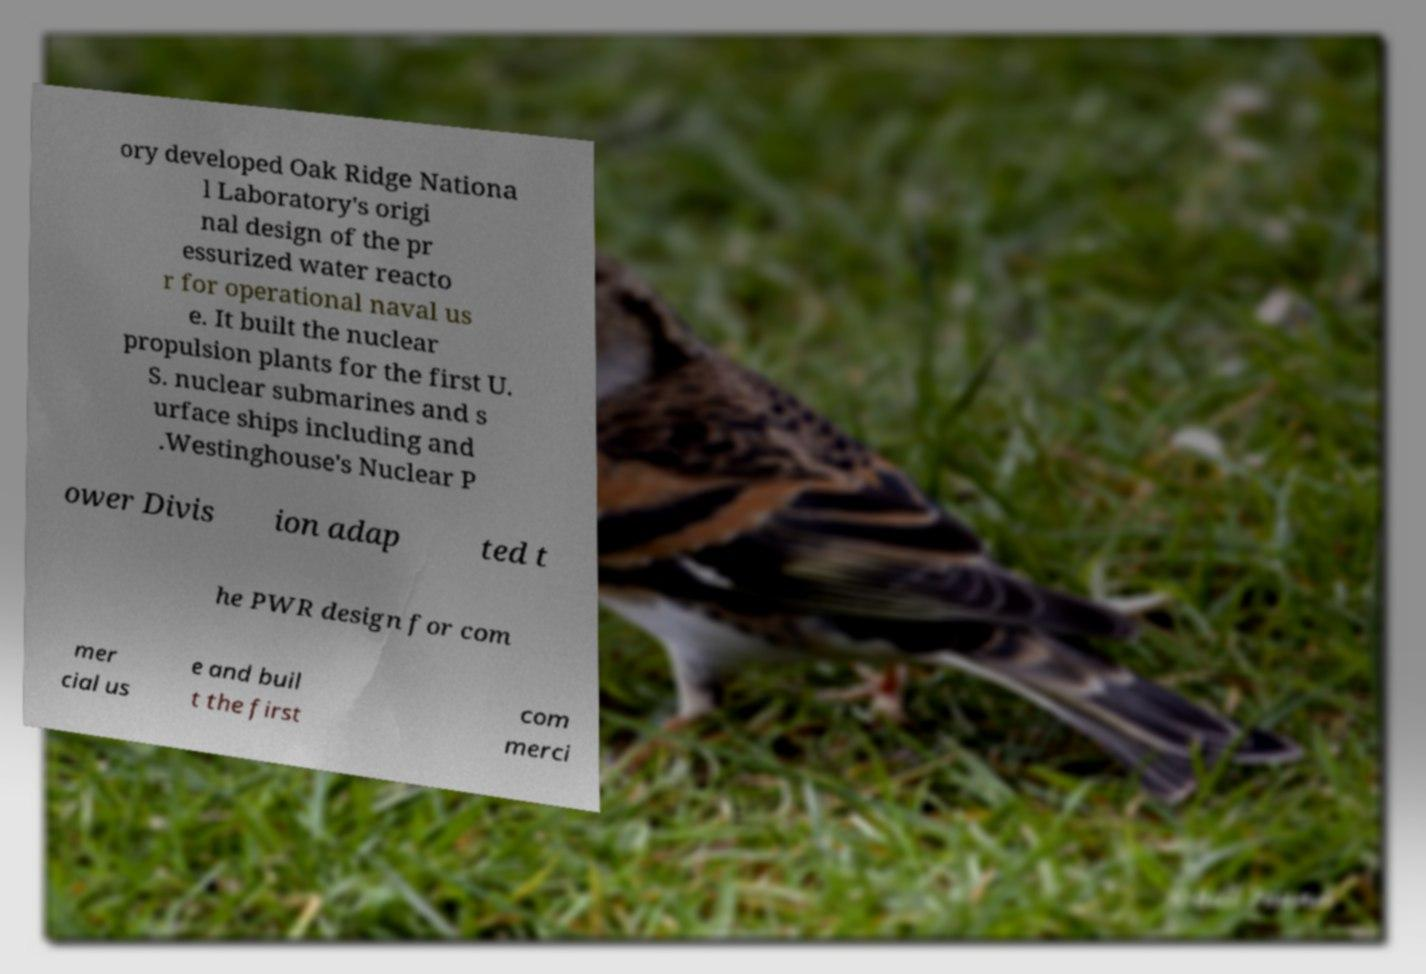Please read and relay the text visible in this image. What does it say? ory developed Oak Ridge Nationa l Laboratory's origi nal design of the pr essurized water reacto r for operational naval us e. It built the nuclear propulsion plants for the first U. S. nuclear submarines and s urface ships including and .Westinghouse's Nuclear P ower Divis ion adap ted t he PWR design for com mer cial us e and buil t the first com merci 